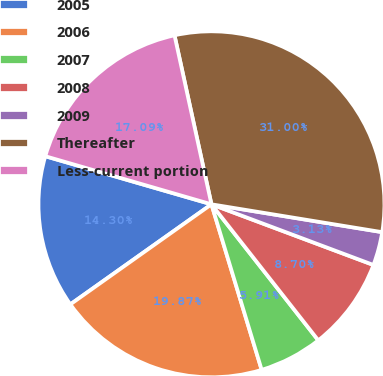Convert chart. <chart><loc_0><loc_0><loc_500><loc_500><pie_chart><fcel>2005<fcel>2006<fcel>2007<fcel>2008<fcel>2009<fcel>Thereafter<fcel>Less-current portion<nl><fcel>14.3%<fcel>19.87%<fcel>5.91%<fcel>8.7%<fcel>3.13%<fcel>31.0%<fcel>17.09%<nl></chart> 